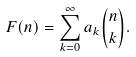Convert formula to latex. <formula><loc_0><loc_0><loc_500><loc_500>F ( n ) = \sum _ { k = 0 } ^ { \infty } a _ { k } \binom { n } { k } .</formula> 